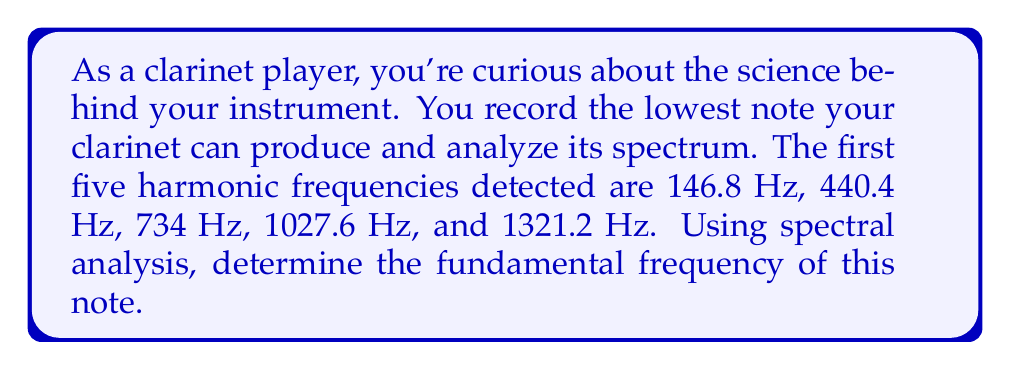Could you help me with this problem? Let's approach this step-by-step:

1) In spectral analysis, the fundamental frequency ($f_0$) is the greatest common divisor (GCD) of all the harmonic frequencies.

2) For a clarinet, which is a closed-pipe instrument, the harmonic series follows the odd-integer multiples of the fundamental frequency:

   $f_n = (2n+1)f_0$, where $n = 0, 1, 2, ...$

3) Let's write out the relationship between each harmonic and the fundamental:

   $146.8 = f_0$
   $440.4 = 3f_0$
   $734.0 = 5f_0$
   $1027.6 = 7f_0$
   $1321.2 = 9f_0$

4) To find $f_0$, we can divide each frequency by its corresponding odd number:

   $146.8 / 1 = 146.8$
   $440.4 / 3 = 146.8$
   $734.0 / 5 = 146.8$
   $1027.6 / 7 = 146.8$
   $1321.2 / 9 = 146.8$

5) We can see that all these divisions result in the same value, 146.8 Hz.

6) This confirms that 146.8 Hz is indeed the fundamental frequency of the note.
Answer: $146.8 \text{ Hz}$ 